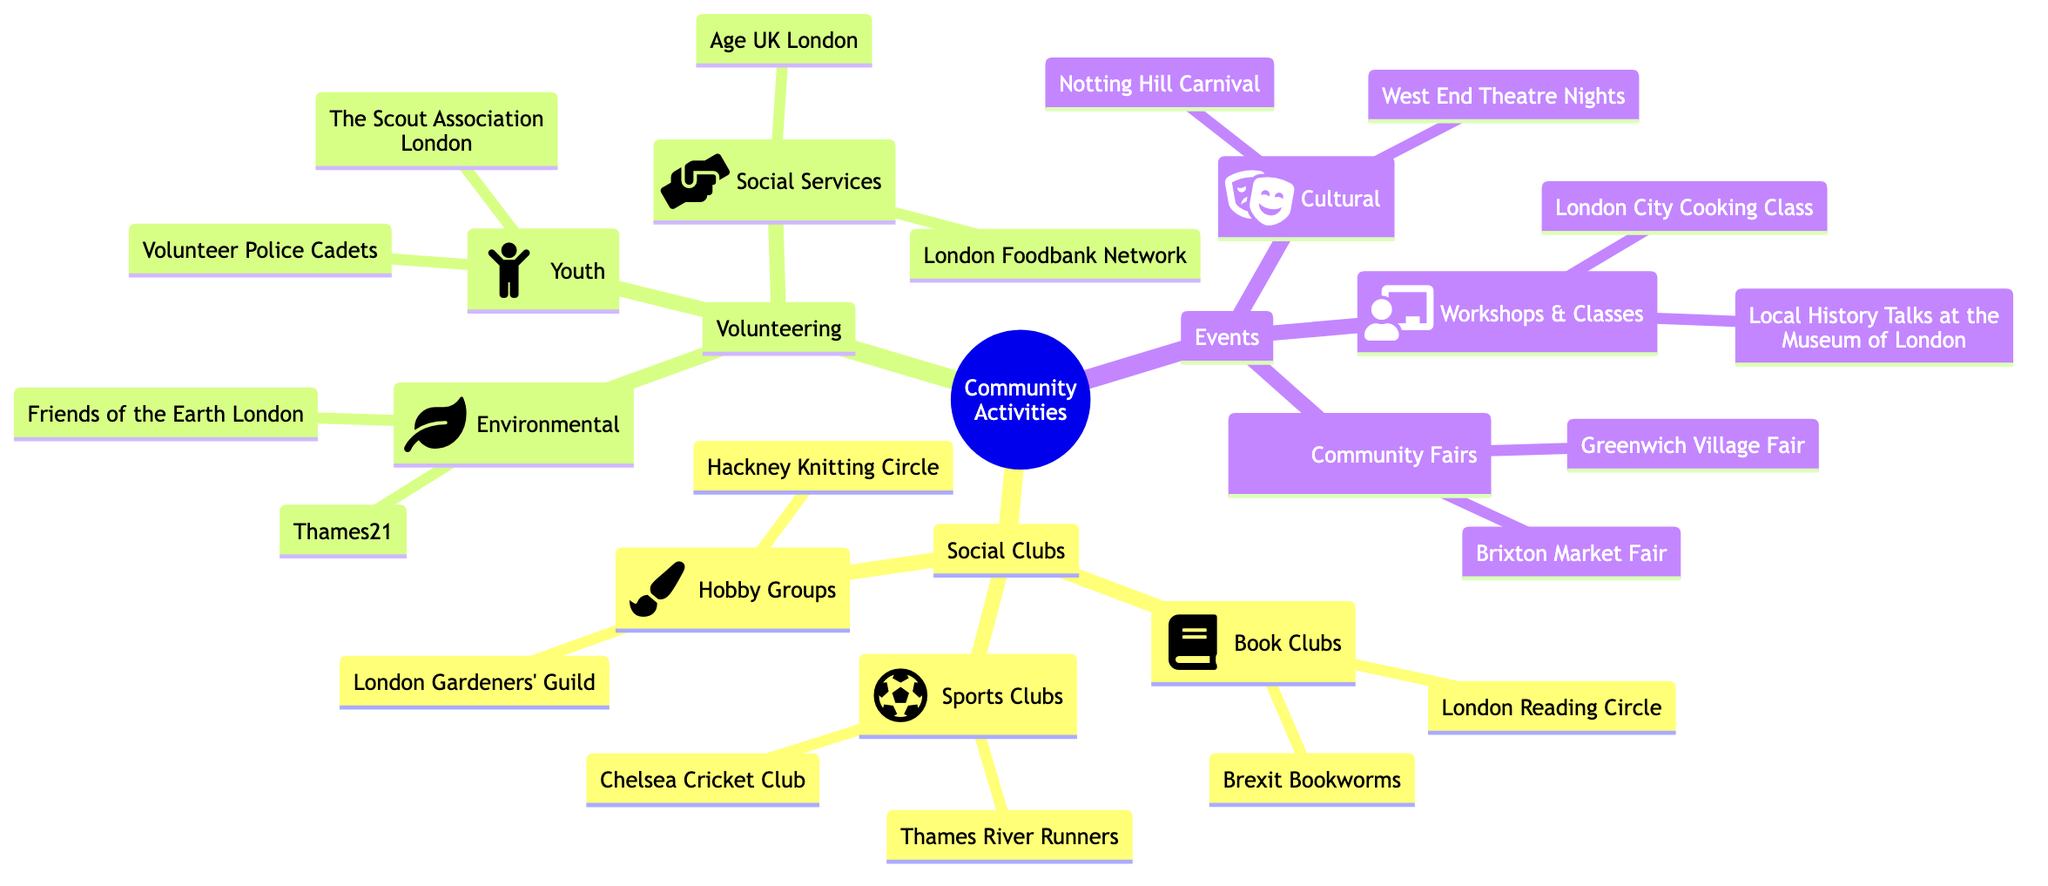What type of clubs are included under Social Clubs? The diagram lists three types of clubs under Social Clubs: Book Clubs, Sports Clubs, and Hobby Groups. Each of these categories contains specific examples of clubs.
Answer: Book Clubs, Sports Clubs, Hobby Groups How many volunteering categories are listed? By examining the Volunteering section of the diagram, we can see there are three distinct categories: Environmental, Social Services, and Youth.
Answer: 3 What is the name of one cultural event? The Cultural section lists two events, and either can be an acceptable answer. Examining this section reveals "Notting Hill Carnival" as one of the events.
Answer: Notting Hill Carnival Which social service volunteer group helps the elderly? In the Volunteering section, under the Social Services category, "Age UK London" is explicitly mentioned as an organization focused on helping elderly individuals.
Answer: Age UK London Which hobby group focuses on gardening? The Hobby Groups under Social Clubs include "London Gardeners' Guild," which specifically brings attention to gardening activities. A simple look at this section confirms this club's specialty.
Answer: London Gardeners' Guild How many workshops & classes are mentioned in the Events category? Closely examining the Workshops & Classes under the Events, we can see two specific offerings: "London City Cooking Class" and "Local History Talks at the Museum of London." Thus, we can count these two workshops.
Answer: 2 Which sport is represented by the Chelsea club? By referring to the Sports Clubs section of the Social Clubs category, "Chelsea Cricket Club" indicates that cricket is the sport associated with this specific club.
Answer: Cricket Name one environmental volunteering group. Within the Environmental volunteering category, "Friends of the Earth London" is a specific group that is easily identifiable by just reading through this part of the diagram.
Answer: Friends of the Earth London 